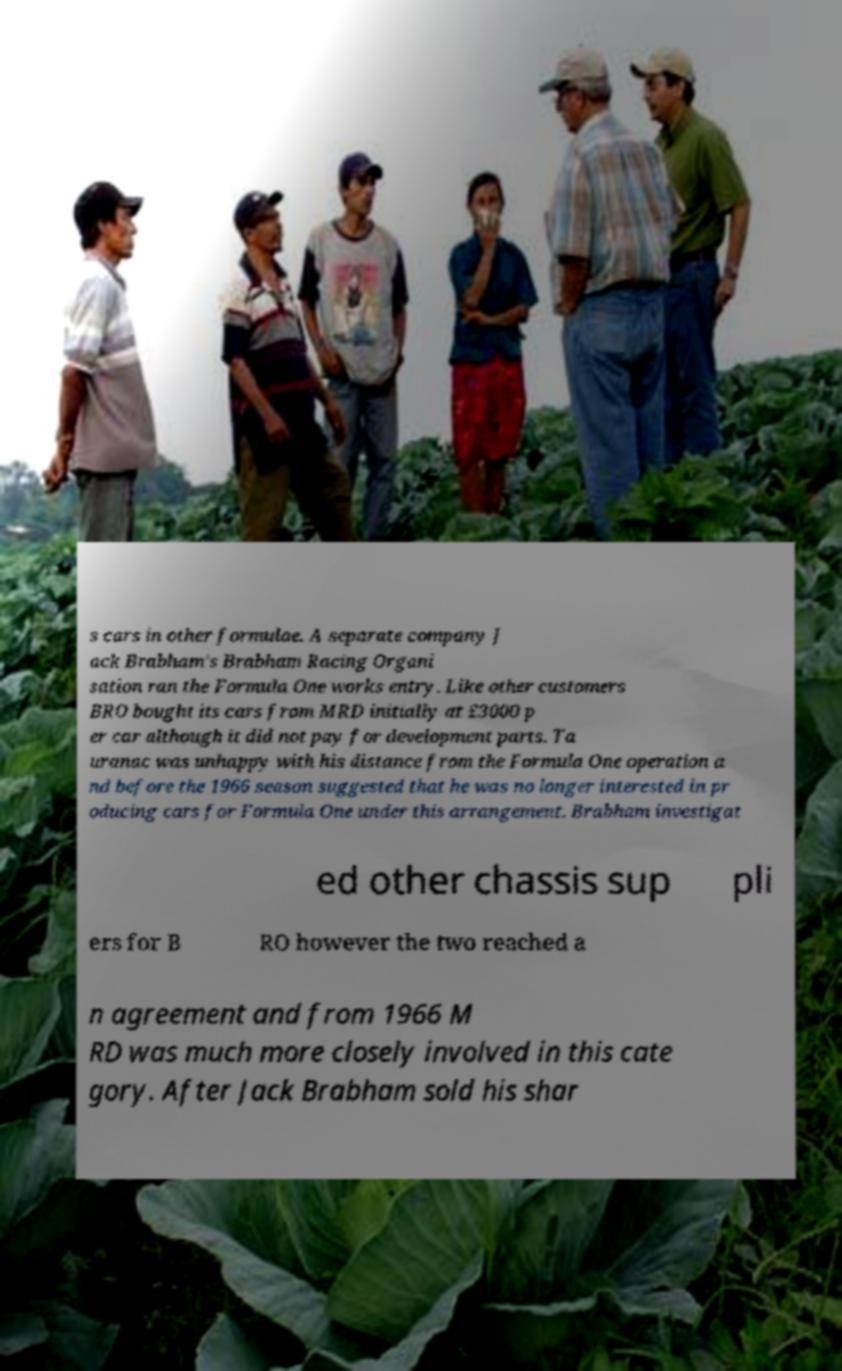Can you read and provide the text displayed in the image?This photo seems to have some interesting text. Can you extract and type it out for me? s cars in other formulae. A separate company J ack Brabham's Brabham Racing Organi sation ran the Formula One works entry. Like other customers BRO bought its cars from MRD initially at £3000 p er car although it did not pay for development parts. Ta uranac was unhappy with his distance from the Formula One operation a nd before the 1966 season suggested that he was no longer interested in pr oducing cars for Formula One under this arrangement. Brabham investigat ed other chassis sup pli ers for B RO however the two reached a n agreement and from 1966 M RD was much more closely involved in this cate gory. After Jack Brabham sold his shar 